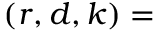<formula> <loc_0><loc_0><loc_500><loc_500>( r , d , k ) =</formula> 